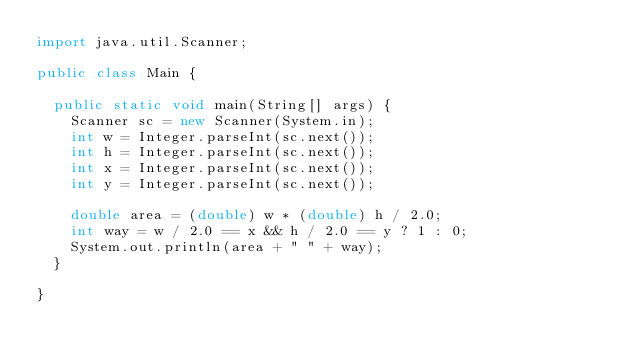<code> <loc_0><loc_0><loc_500><loc_500><_Java_>import java.util.Scanner;

public class Main {

	public static void main(String[] args) {
		Scanner sc = new Scanner(System.in);
		int w = Integer.parseInt(sc.next());
		int h = Integer.parseInt(sc.next());
		int x = Integer.parseInt(sc.next());
		int y = Integer.parseInt(sc.next());

		double area = (double) w * (double) h / 2.0;
		int way = w / 2.0 == x && h / 2.0 == y ? 1 : 0;
		System.out.println(area + " " + way);
	}

}
</code> 